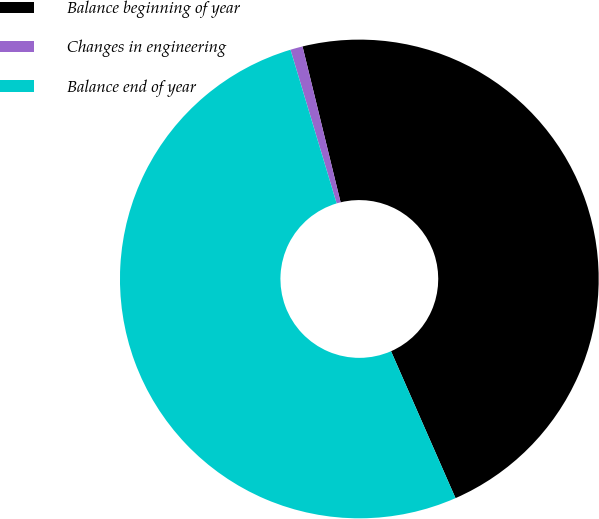Convert chart. <chart><loc_0><loc_0><loc_500><loc_500><pie_chart><fcel>Balance beginning of year<fcel>Changes in engineering<fcel>Balance end of year<nl><fcel>47.23%<fcel>0.83%<fcel>51.94%<nl></chart> 